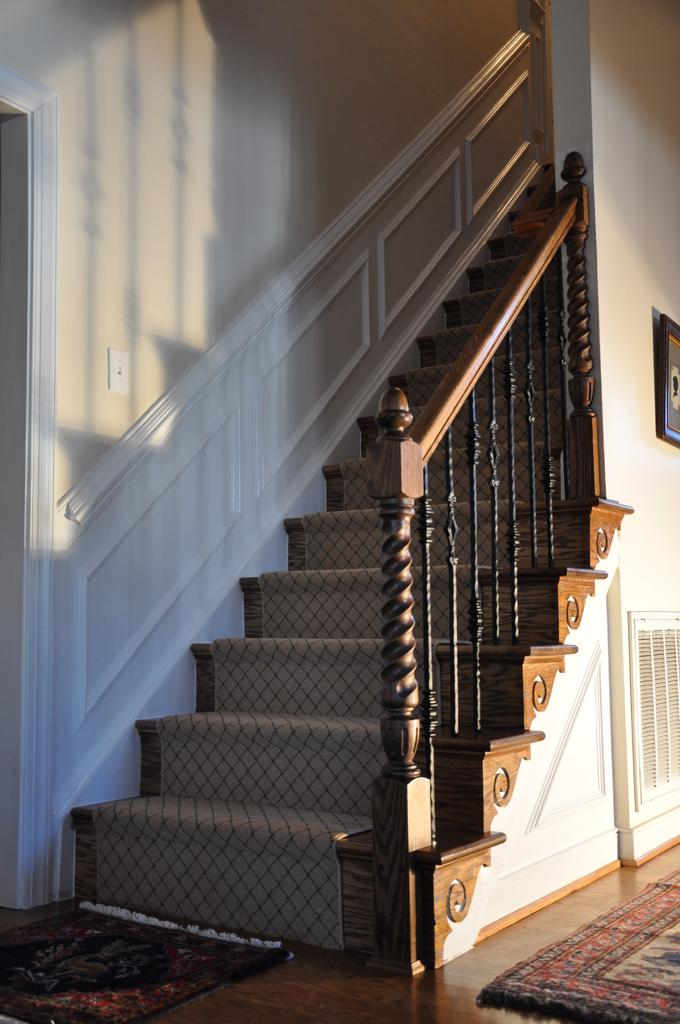What is the primary surface visible in the image? There is a floor in the image. What is placed on the floor? There are mats on the floor. What architectural feature can be seen in the background of the image? There are stairs in the background of the image. What else is visible in the background of the image? There are walls in the background of the image. What type of engine can be seen on the page in the image? There is no engine or page present in the image. 